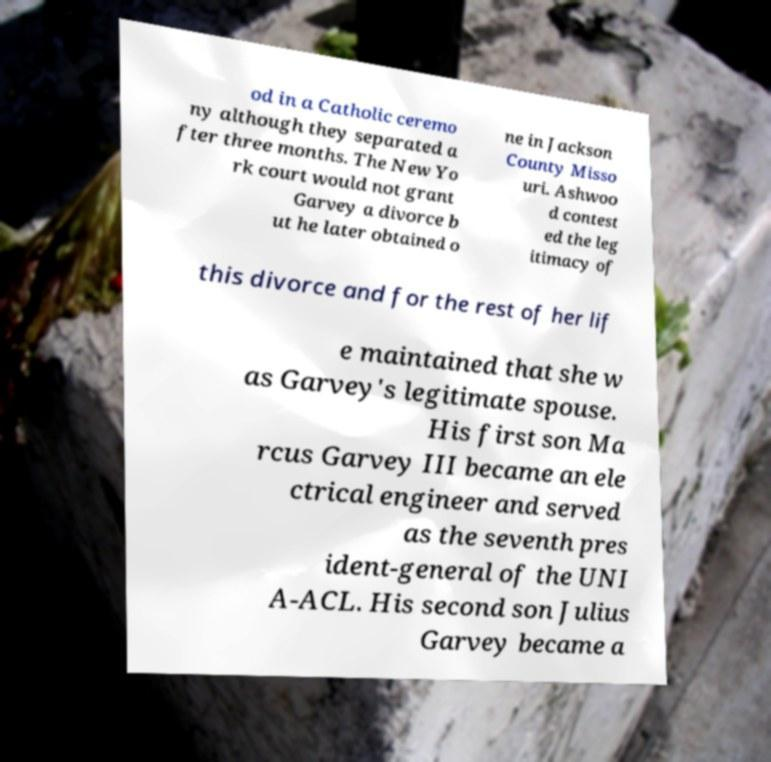Could you assist in decoding the text presented in this image and type it out clearly? od in a Catholic ceremo ny although they separated a fter three months. The New Yo rk court would not grant Garvey a divorce b ut he later obtained o ne in Jackson County Misso uri. Ashwoo d contest ed the leg itimacy of this divorce and for the rest of her lif e maintained that she w as Garvey's legitimate spouse. His first son Ma rcus Garvey III became an ele ctrical engineer and served as the seventh pres ident-general of the UNI A-ACL. His second son Julius Garvey became a 